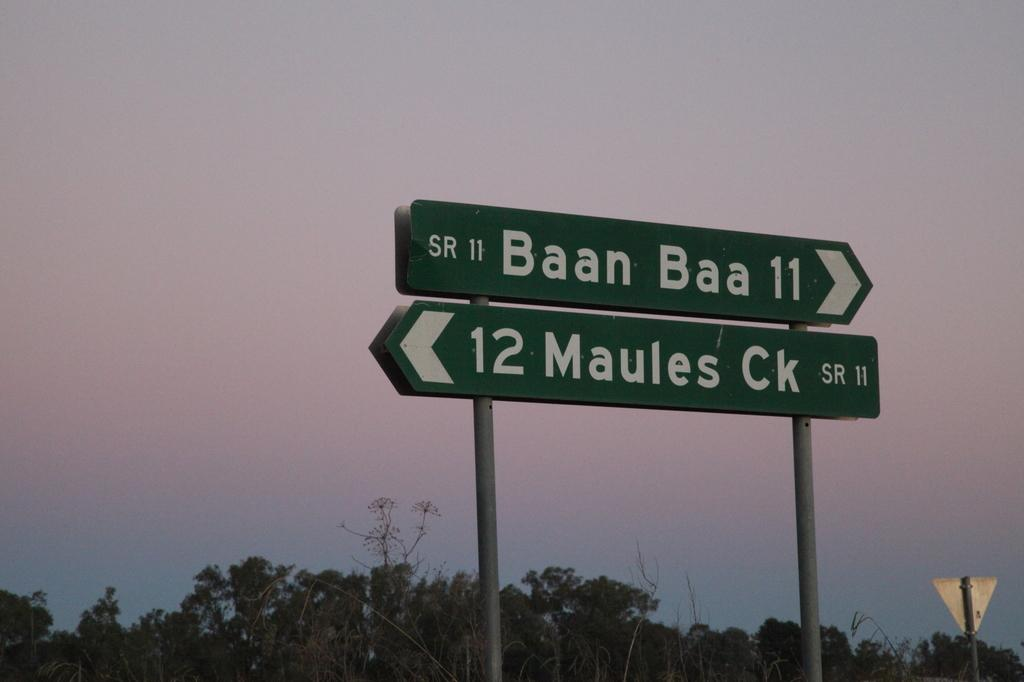<image>
Provide a brief description of the given image. a baan sign that is above another sign 